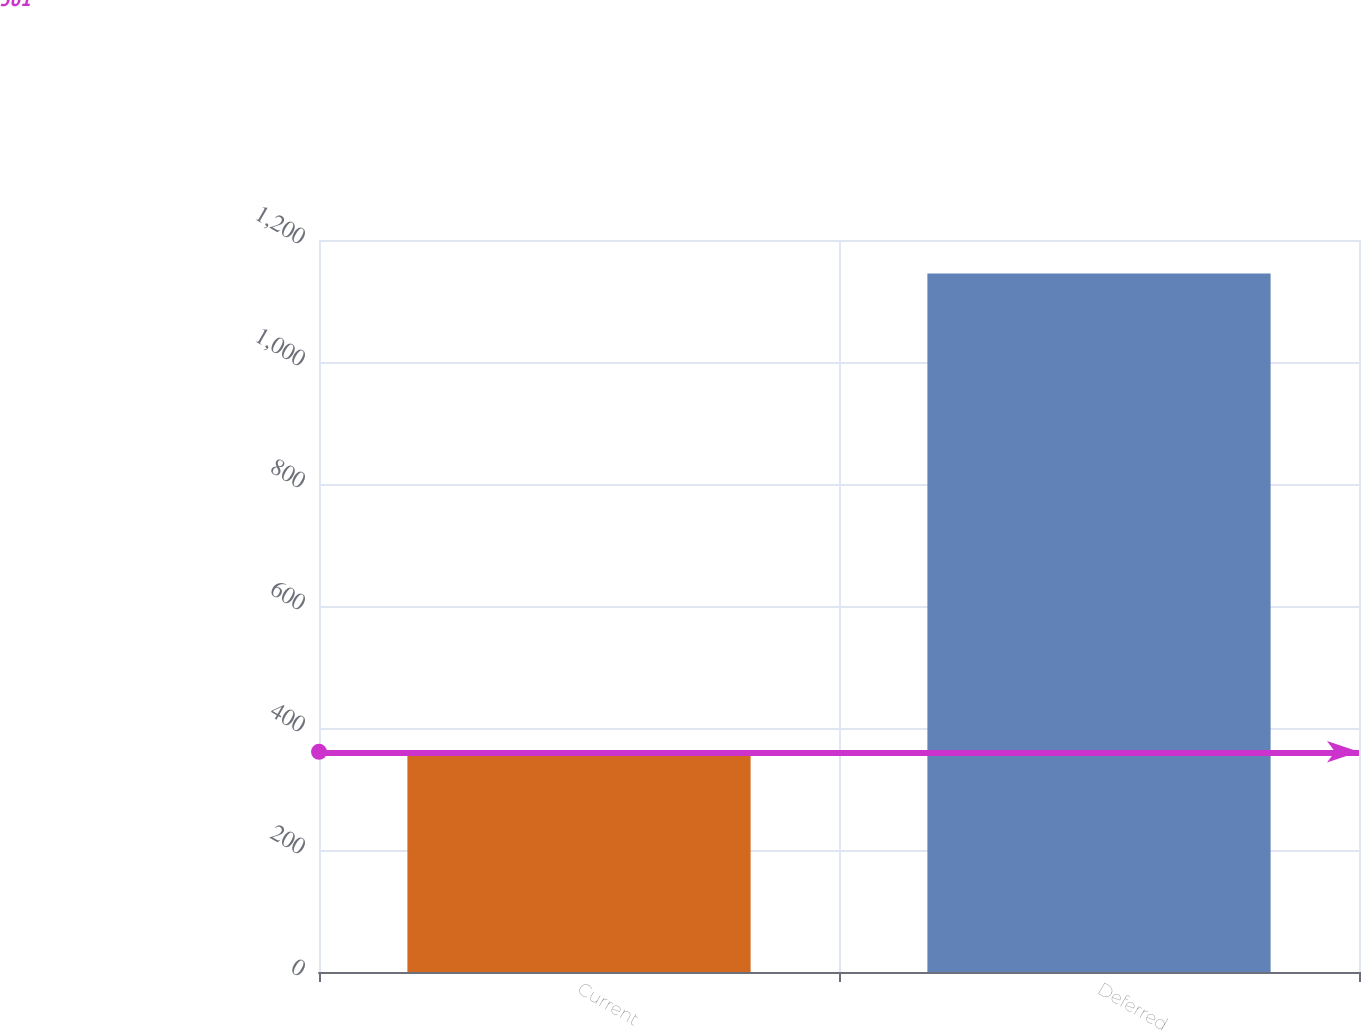Convert chart to OTSL. <chart><loc_0><loc_0><loc_500><loc_500><bar_chart><fcel>Current<fcel>Deferred<nl><fcel>361<fcel>1145<nl></chart> 